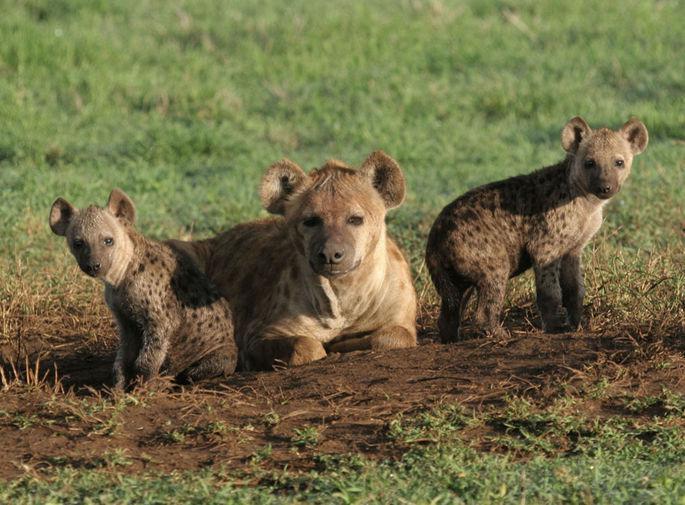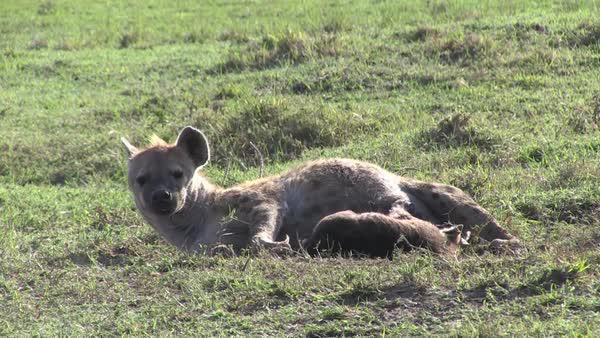The first image is the image on the left, the second image is the image on the right. Examine the images to the left and right. Is the description "One hyena is lying on the ground with a baby near it in the image on the right." accurate? Answer yes or no. Yes. The first image is the image on the left, the second image is the image on the right. Considering the images on both sides, is "An image shows an adult hyena lying down horizontally with head to the left, in close proximity to at least one hyena pup." valid? Answer yes or no. Yes. 